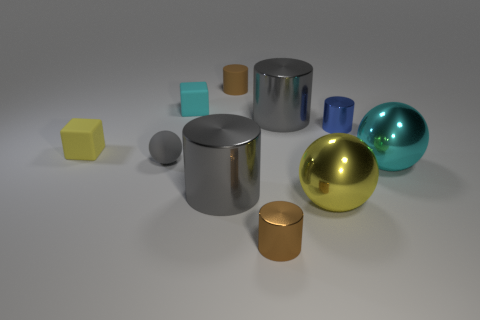Subtract all brown cylinders. How many were subtracted if there are1brown cylinders left? 1 Subtract all blue cylinders. How many cylinders are left? 4 Subtract all blue cylinders. How many cylinders are left? 4 Subtract all red cylinders. Subtract all red cubes. How many cylinders are left? 5 Subtract all balls. How many objects are left? 7 Add 4 tiny gray balls. How many tiny gray balls are left? 5 Add 1 big red objects. How many big red objects exist? 1 Subtract 0 purple cylinders. How many objects are left? 10 Subtract all brown shiny cylinders. Subtract all small matte blocks. How many objects are left? 7 